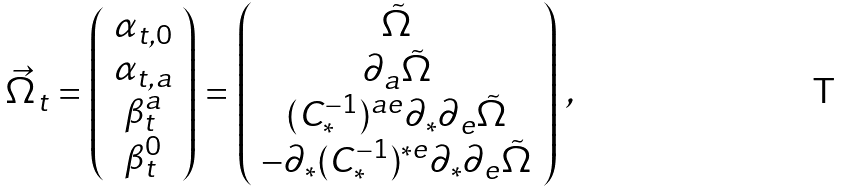<formula> <loc_0><loc_0><loc_500><loc_500>\vec { \Omega } _ { t } = \left ( \begin{array} { c } \alpha _ { t , 0 } \\ \alpha _ { t , a } \\ \beta _ { t } ^ { a } \\ \beta _ { t } ^ { 0 } \end{array} \right ) = \left ( \begin{array} { c } \tilde { \Omega } \\ \partial _ { a } \tilde { \Omega } \\ ( C _ { * } ^ { - 1 } ) ^ { a e } \partial _ { * } \partial _ { e } \tilde { \Omega } \\ - \partial _ { * } ( C _ { * } ^ { - 1 } ) ^ { * e } \partial _ { * } \partial _ { e } \tilde { \Omega } \end{array} \right ) \, ,</formula> 